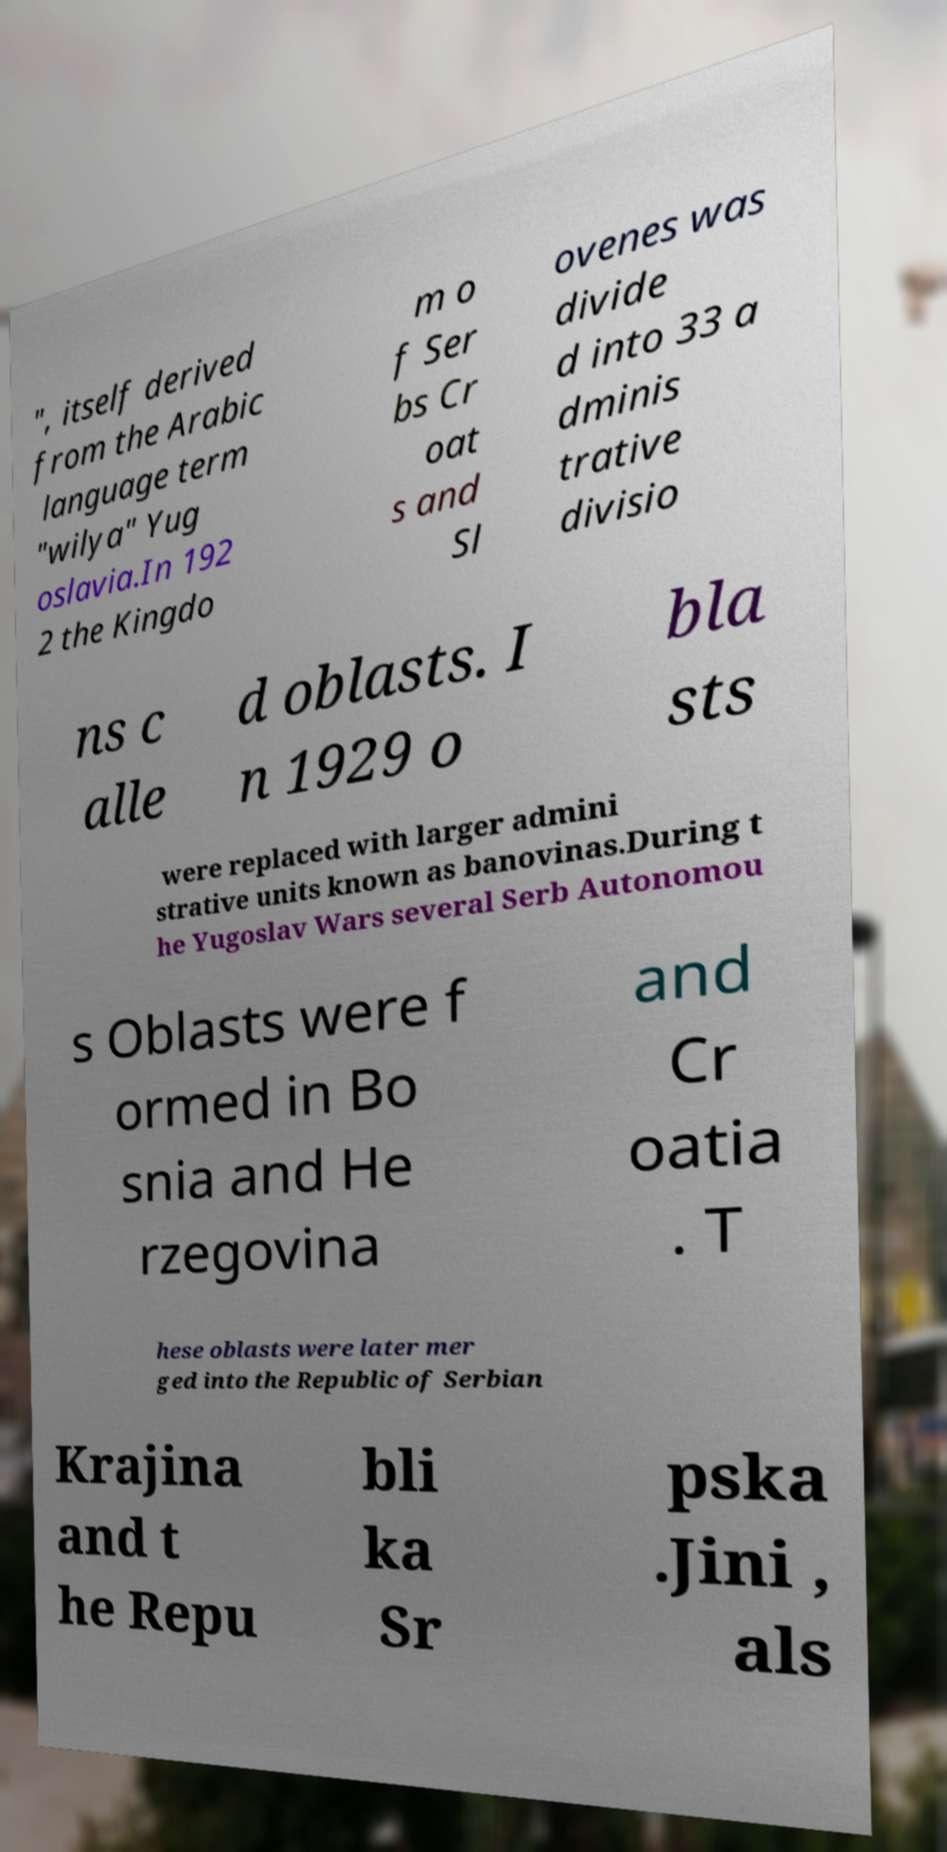For documentation purposes, I need the text within this image transcribed. Could you provide that? ", itself derived from the Arabic language term "wilya" Yug oslavia.In 192 2 the Kingdo m o f Ser bs Cr oat s and Sl ovenes was divide d into 33 a dminis trative divisio ns c alle d oblasts. I n 1929 o bla sts were replaced with larger admini strative units known as banovinas.During t he Yugoslav Wars several Serb Autonomou s Oblasts were f ormed in Bo snia and He rzegovina and Cr oatia . T hese oblasts were later mer ged into the Republic of Serbian Krajina and t he Repu bli ka Sr pska .Jini , als 